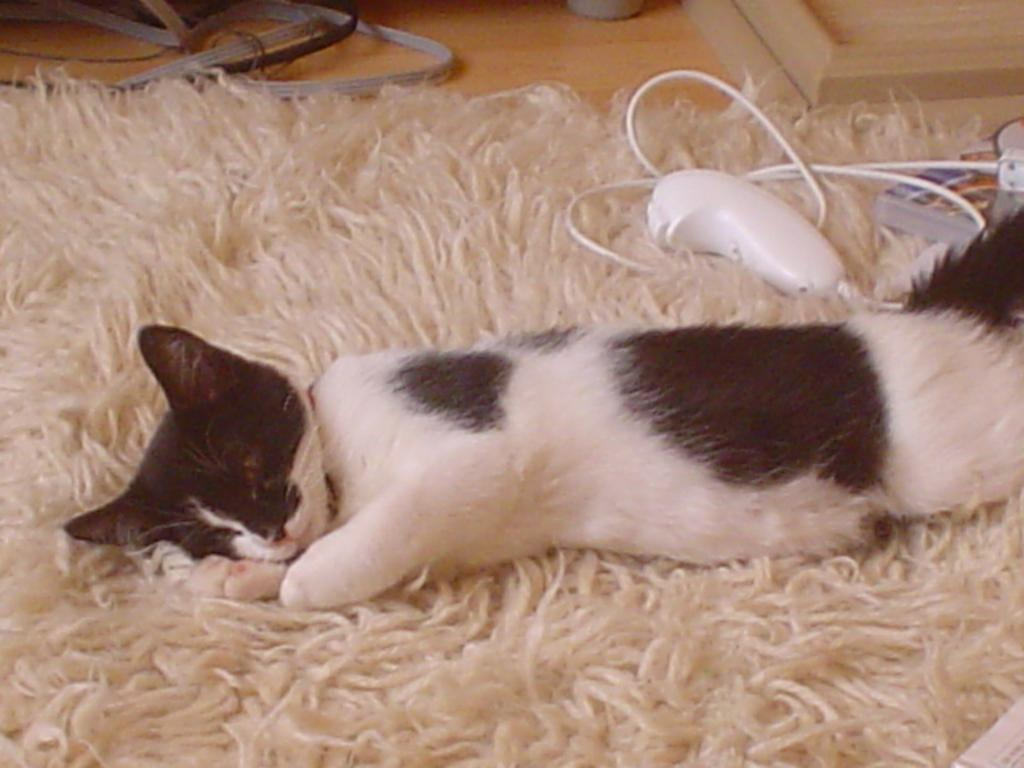What type of animal is in the image? There is a cat in the image. Where is the cat located? The cat is on a mat. What else can be seen in the image besides the cat? There is a book and a hand joystick in the image. What is present on the floor in the image? There are wires on the floor in the image. What is the chance of the cat swinging on the wires in the image? There is no swing or any indication that the cat will interact with the wires in the image. 